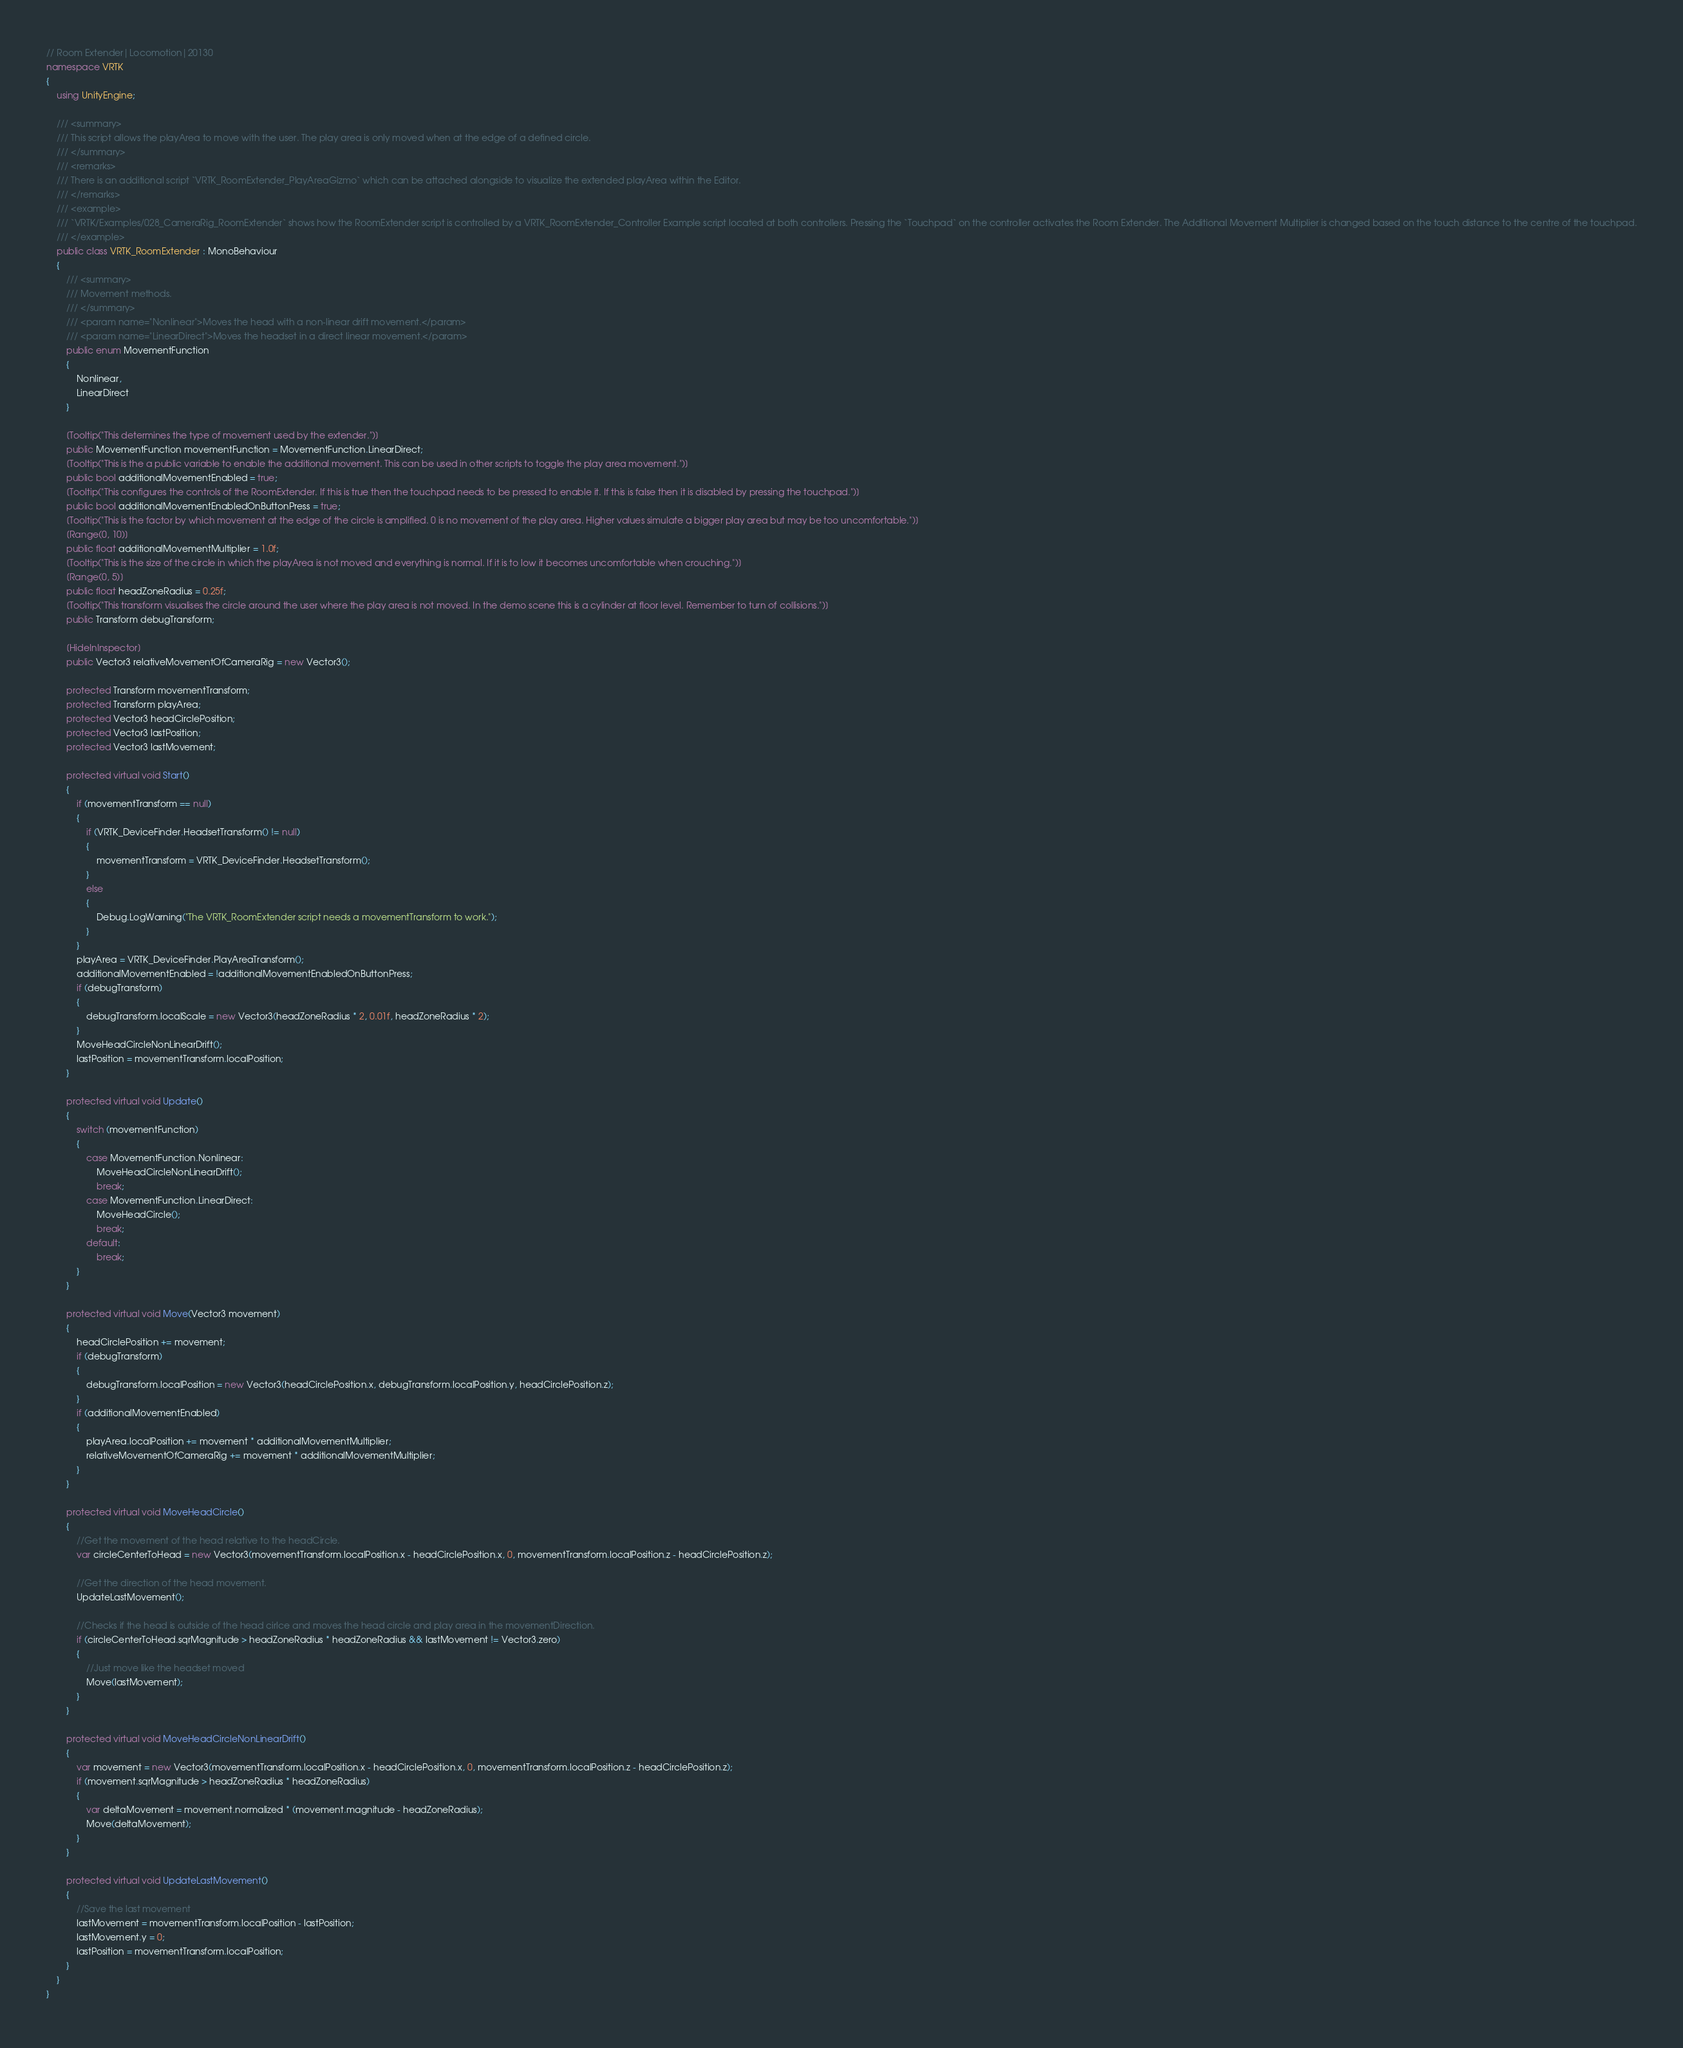<code> <loc_0><loc_0><loc_500><loc_500><_C#_>// Room Extender|Locomotion|20130
namespace VRTK
{
    using UnityEngine;

    /// <summary>
    /// This script allows the playArea to move with the user. The play area is only moved when at the edge of a defined circle.
    /// </summary>
    /// <remarks>
    /// There is an additional script `VRTK_RoomExtender_PlayAreaGizmo` which can be attached alongside to visualize the extended playArea within the Editor.
    /// </remarks>
    /// <example>
    /// `VRTK/Examples/028_CameraRig_RoomExtender` shows how the RoomExtender script is controlled by a VRTK_RoomExtender_Controller Example script located at both controllers. Pressing the `Touchpad` on the controller activates the Room Extender. The Additional Movement Multiplier is changed based on the touch distance to the centre of the touchpad.
    /// </example>
    public class VRTK_RoomExtender : MonoBehaviour
    {
        /// <summary>
        /// Movement methods.
        /// </summary>
        /// <param name="Nonlinear">Moves the head with a non-linear drift movement.</param>
        /// <param name="LinearDirect">Moves the headset in a direct linear movement.</param>
        public enum MovementFunction
        {
            Nonlinear,
            LinearDirect
        }

        [Tooltip("This determines the type of movement used by the extender.")]
        public MovementFunction movementFunction = MovementFunction.LinearDirect;
        [Tooltip("This is the a public variable to enable the additional movement. This can be used in other scripts to toggle the play area movement.")]
        public bool additionalMovementEnabled = true;
        [Tooltip("This configures the controls of the RoomExtender. If this is true then the touchpad needs to be pressed to enable it. If this is false then it is disabled by pressing the touchpad.")]
        public bool additionalMovementEnabledOnButtonPress = true;
        [Tooltip("This is the factor by which movement at the edge of the circle is amplified. 0 is no movement of the play area. Higher values simulate a bigger play area but may be too uncomfortable.")]
        [Range(0, 10)]
        public float additionalMovementMultiplier = 1.0f;
        [Tooltip("This is the size of the circle in which the playArea is not moved and everything is normal. If it is to low it becomes uncomfortable when crouching.")]
        [Range(0, 5)]
        public float headZoneRadius = 0.25f;
        [Tooltip("This transform visualises the circle around the user where the play area is not moved. In the demo scene this is a cylinder at floor level. Remember to turn of collisions.")]
        public Transform debugTransform;

        [HideInInspector]
        public Vector3 relativeMovementOfCameraRig = new Vector3();

        protected Transform movementTransform;
        protected Transform playArea;
        protected Vector3 headCirclePosition;
        protected Vector3 lastPosition;
        protected Vector3 lastMovement;

        protected virtual void Start()
        {
            if (movementTransform == null)
            {
                if (VRTK_DeviceFinder.HeadsetTransform() != null)
                {
                    movementTransform = VRTK_DeviceFinder.HeadsetTransform();
                }
                else
                {
                    Debug.LogWarning("The VRTK_RoomExtender script needs a movementTransform to work.");
                }
            }
            playArea = VRTK_DeviceFinder.PlayAreaTransform();
            additionalMovementEnabled = !additionalMovementEnabledOnButtonPress;
            if (debugTransform)
            {
                debugTransform.localScale = new Vector3(headZoneRadius * 2, 0.01f, headZoneRadius * 2);
            }
            MoveHeadCircleNonLinearDrift();
            lastPosition = movementTransform.localPosition;
        }

        protected virtual void Update()
        {
            switch (movementFunction)
            {
                case MovementFunction.Nonlinear:
                    MoveHeadCircleNonLinearDrift();
                    break;
                case MovementFunction.LinearDirect:
                    MoveHeadCircle();
                    break;
                default:
                    break;
            }
        }

        protected virtual void Move(Vector3 movement)
        {
            headCirclePosition += movement;
            if (debugTransform)
            {
                debugTransform.localPosition = new Vector3(headCirclePosition.x, debugTransform.localPosition.y, headCirclePosition.z);
            }
            if (additionalMovementEnabled)
            {
                playArea.localPosition += movement * additionalMovementMultiplier;
                relativeMovementOfCameraRig += movement * additionalMovementMultiplier;
            }
        }

        protected virtual void MoveHeadCircle()
        {
            //Get the movement of the head relative to the headCircle.
            var circleCenterToHead = new Vector3(movementTransform.localPosition.x - headCirclePosition.x, 0, movementTransform.localPosition.z - headCirclePosition.z);

            //Get the direction of the head movement.
            UpdateLastMovement();

            //Checks if the head is outside of the head cirlce and moves the head circle and play area in the movementDirection.
            if (circleCenterToHead.sqrMagnitude > headZoneRadius * headZoneRadius && lastMovement != Vector3.zero)
            {
                //Just move like the headset moved
                Move(lastMovement);
            }
        }

        protected virtual void MoveHeadCircleNonLinearDrift()
        {
            var movement = new Vector3(movementTransform.localPosition.x - headCirclePosition.x, 0, movementTransform.localPosition.z - headCirclePosition.z);
            if (movement.sqrMagnitude > headZoneRadius * headZoneRadius)
            {
                var deltaMovement = movement.normalized * (movement.magnitude - headZoneRadius);
                Move(deltaMovement);
            }
        }

        protected virtual void UpdateLastMovement()
        {
            //Save the last movement
            lastMovement = movementTransform.localPosition - lastPosition;
            lastMovement.y = 0;
            lastPosition = movementTransform.localPosition;
        }
    }
}</code> 